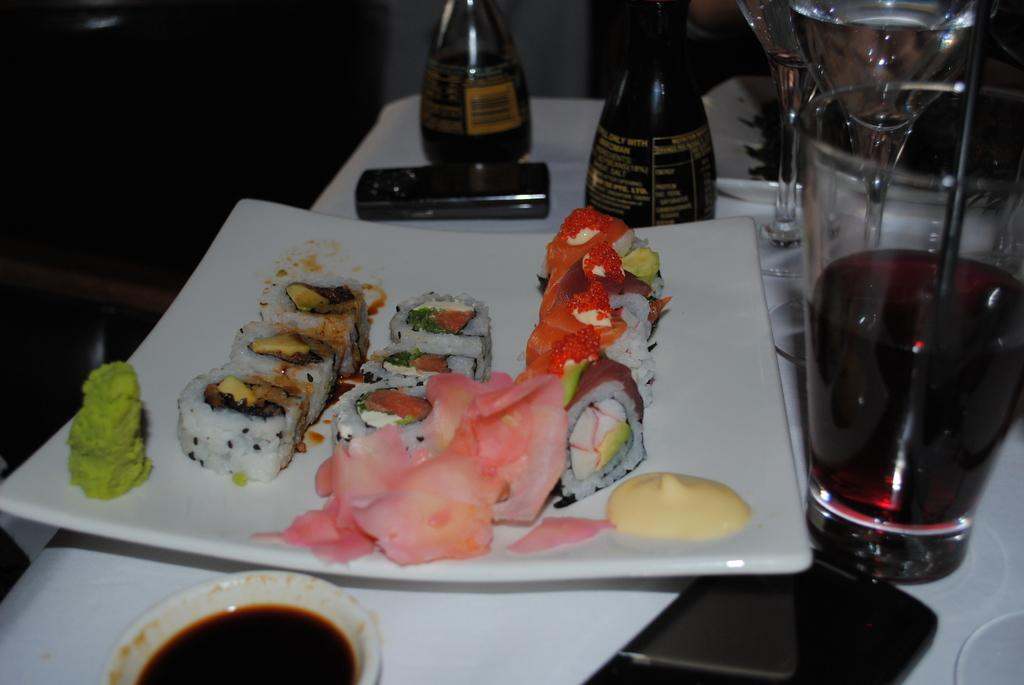What is on the plate in the image? There are food items on a white color plate in the image. What can be seen on the table besides the plate? There are wine glasses on the table in the image. Where is the mobile phone located in the image? The mobile phone is at the bottom of the image. How many cattle are visible in the image? There are no cattle present in the image. What type of wire is used to hold the food items on the plate? There is no wire visible in the image; the food items are on a white color plate. 